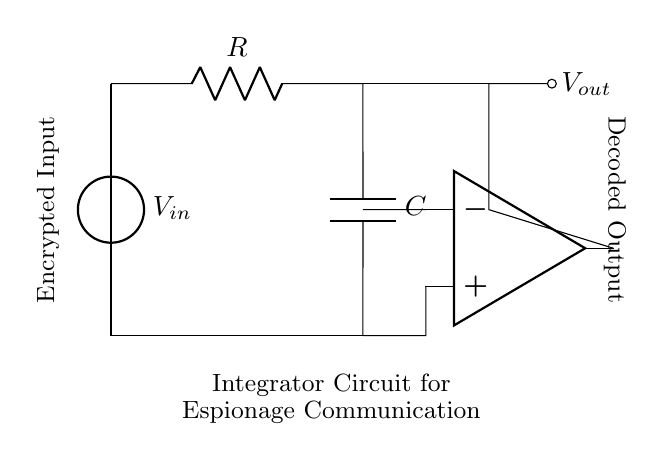What is the input voltage type? The circuit diagram indicates an input voltage source represented by \(V_{in}\), which is labeled in the diagram as a voltage source.
Answer: Voltage source What components make up the integrator circuit? The integrator circuit in the diagram consists of a resistor \(R\) and a capacitor \(C\), along with an operational amplifier. These components are essential for its function.
Answer: Resistor and capacitor What is connected to the output of the operational amplifier? The output of the operational amplifier is connected to the node labeled \(V_{out}\), indicating the decoded output of the integrator circuit.
Answer: Decoded output What role does the resistor play in this circuit? The resistor \(R\) limits the current flowing into the capacitor, creating a time constant that is crucial for the integration process of the input signal.
Answer: Current limiting How does the capacitor affect the output signal? The capacitor \(C\) integrates the input voltage over time, causing the output to represent the accumulated charge which corresponds to the integrated value of the input signal.
Answer: Integration What is the purpose of this integrator circuit in espionage communication? The purpose of the integrator circuit in this context is to decode encrypted messages by processing the input signals and transforming them into intelligible outputs.
Answer: Decoding encrypted messages 